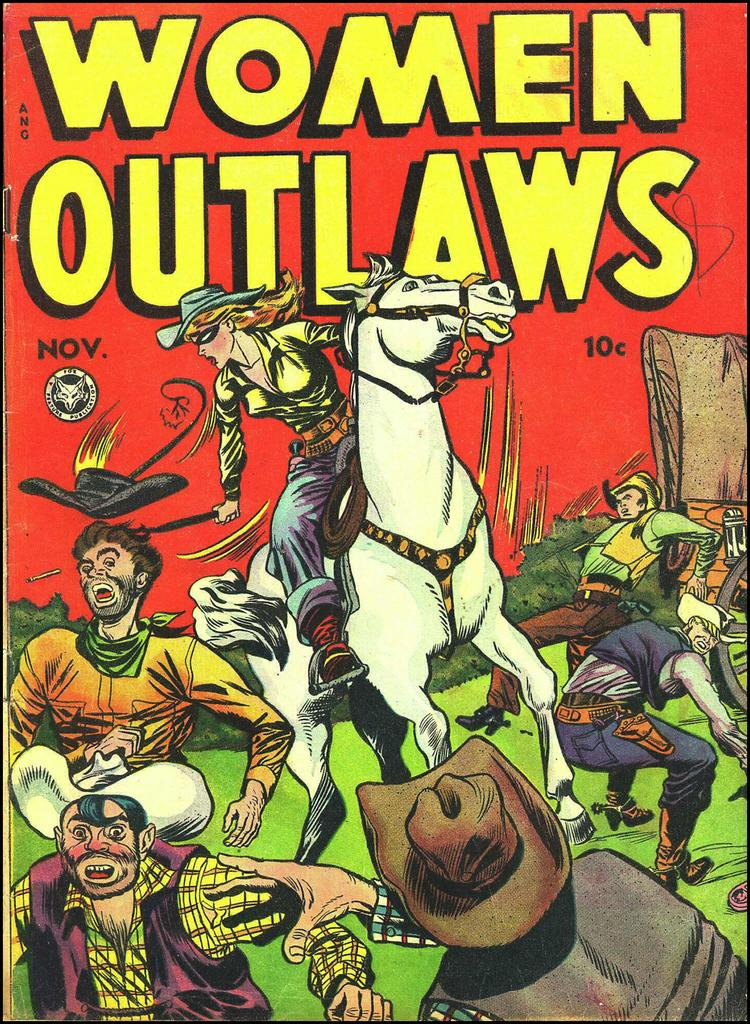Provide a one-sentence caption for the provided image. A comic book edition of Women Outlaws where a woman rides a white horse and is fighting cowboys. 